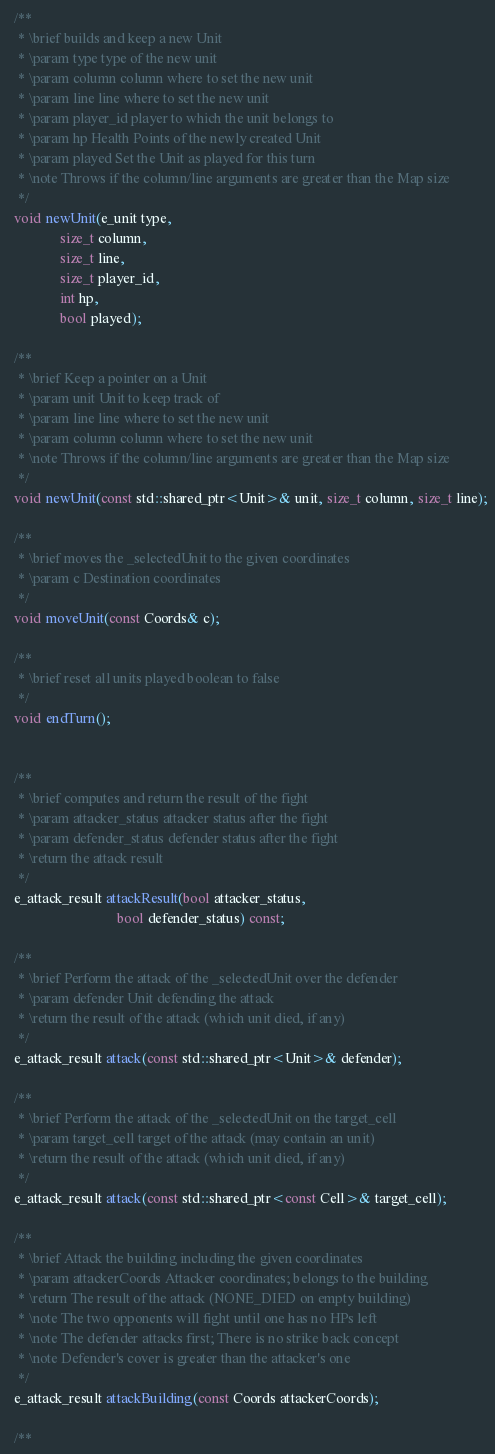<code> <loc_0><loc_0><loc_500><loc_500><_C++_>
  /**
   * \brief builds and keep a new Unit
   * \param type type of the new unit
   * \param column column where to set the new unit
   * \param line line where to set the new unit
   * \param player_id player to which the unit belongs to
   * \param hp Health Points of the newly created Unit
   * \param played Set the Unit as played for this turn
   * \note Throws if the column/line arguments are greater than the Map size
   */
  void newUnit(e_unit type,
               size_t column,
               size_t line,
               size_t player_id,
               int hp,
               bool played);

  /**
   * \brief Keep a pointer on a Unit
   * \param unit Unit to keep track of
   * \param line line where to set the new unit
   * \param column column where to set the new unit
   * \note Throws if the column/line arguments are greater than the Map size
   */
  void newUnit(const std::shared_ptr<Unit>& unit, size_t column, size_t line);

  /**
   * \brief moves the _selectedUnit to the given coordinates
   * \param c Destination coordinates
   */
  void moveUnit(const Coords& c);

  /**
   * \brief reset all units played boolean to false
   */
  void endTurn();


  /**
   * \brief computes and return the result of the fight
   * \param attacker_status attacker status after the fight
   * \param defender_status defender status after the fight
   * \return the attack result
   */
  e_attack_result attackResult(bool attacker_status,
                               bool defender_status) const;

  /**
   * \brief Perform the attack of the _selectedUnit over the defender
   * \param defender Unit defending the attack
   * \return the result of the attack (which unit died, if any)
   */
  e_attack_result attack(const std::shared_ptr<Unit>& defender);

  /**
   * \brief Perform the attack of the _selectedUnit on the target_cell
   * \param target_cell target of the attack (may contain an unit)
   * \return the result of the attack (which unit died, if any)
   */
  e_attack_result attack(const std::shared_ptr<const Cell>& target_cell);

  /**
   * \brief Attack the building including the given coordinates
   * \param attackerCoords Attacker coordinates; belongs to the building
   * \return The result of the attack (NONE_DIED on empty building)
   * \note The two opponents will fight until one has no HPs left
   * \note The defender attacks first; There is no strike back concept
   * \note Defender's cover is greater than the attacker's one
   */
  e_attack_result attackBuilding(const Coords attackerCoords);

  /**</code> 